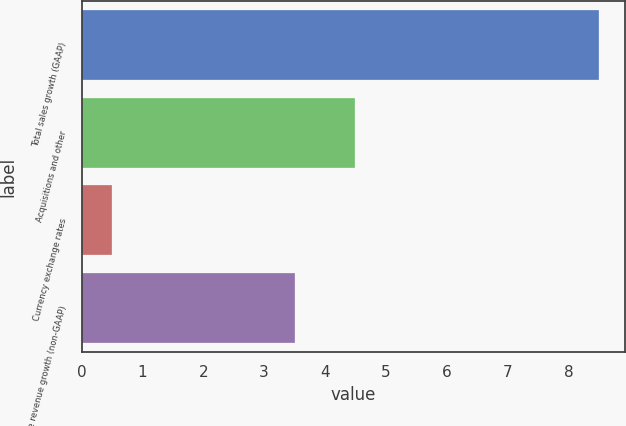<chart> <loc_0><loc_0><loc_500><loc_500><bar_chart><fcel>Total sales growth (GAAP)<fcel>Acquisitions and other<fcel>Currency exchange rates<fcel>Core revenue growth (non-GAAP)<nl><fcel>8.5<fcel>4.5<fcel>0.5<fcel>3.5<nl></chart> 